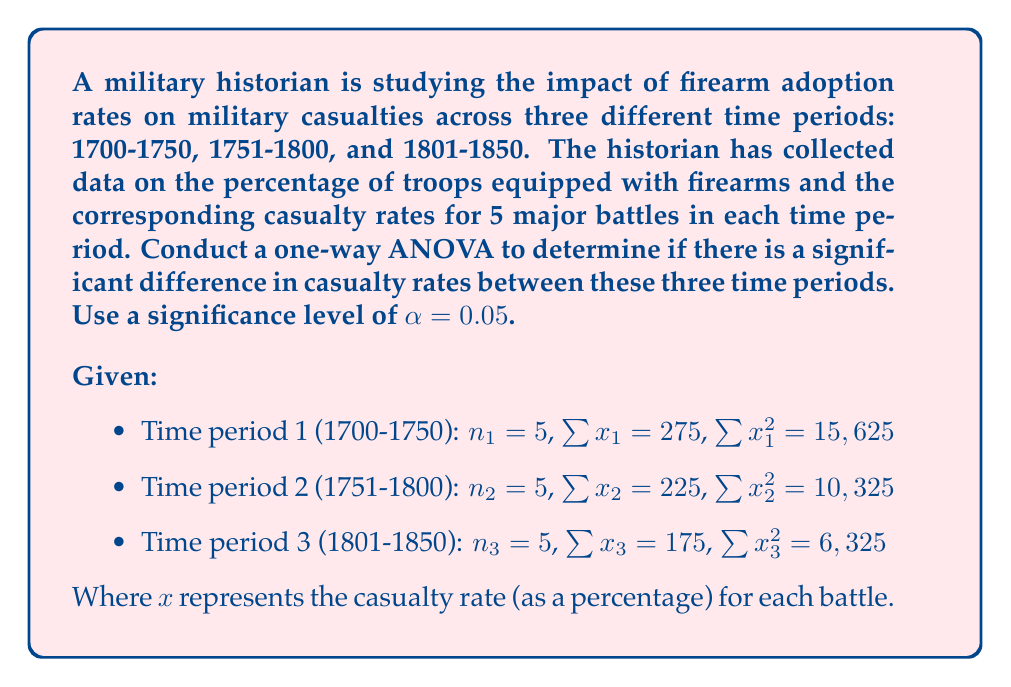Provide a solution to this math problem. To conduct a one-way ANOVA, we need to follow these steps:

1. Calculate the total sum of squares (SST)
2. Calculate the between-group sum of squares (SSB)
3. Calculate the within-group sum of squares (SSW)
4. Calculate the degrees of freedom (df)
5. Calculate the mean squares (MS)
6. Calculate the F-statistic
7. Compare the F-statistic to the critical F-value

Step 1: Calculate SST
First, we need to find the grand mean:
$$\bar{x} = \frac{\sum x_1 + \sum x_2 + \sum x_3}{n_1 + n_2 + n_3} = \frac{275 + 225 + 175}{15} = 45$$

Now, we can calculate SST:
$$SST = \sum x_1^2 + \sum x_2^2 + \sum x_3^2 - \frac{(\sum x_1 + \sum x_2 + \sum x_3)^2}{N}$$
$$SST = 15,625 + 10,325 + 6,325 - \frac{(275 + 225 + 175)^2}{15} = 32,275 - 30,375 = 1,900$$

Step 2: Calculate SSB
$$SSB = \frac{(\sum x_1)^2}{n_1} + \frac{(\sum x_2)^2}{n_2} + \frac{(\sum x_3)^2}{n_3} - \frac{(\sum x_1 + \sum x_2 + \sum x_3)^2}{N}$$
$$SSB = \frac{275^2}{5} + \frac{225^2}{5} + \frac{175^2}{5} - 30,375 = 31,625 - 30,375 = 1,250$$

Step 3: Calculate SSW
$$SSW = SST - SSB = 1,900 - 1,250 = 650$$

Step 4: Calculate degrees of freedom
- Between-group df: $k - 1 = 3 - 1 = 2$
- Within-group df: $N - k = 15 - 3 = 12$
- Total df: $N - 1 = 15 - 1 = 14$

Step 5: Calculate mean squares
$$MSB = \frac{SSB}{df_B} = \frac{1,250}{2} = 625$$
$$MSW = \frac{SSW}{df_W} = \frac{650}{12} = 54.17$$

Step 6: Calculate F-statistic
$$F = \frac{MSB}{MSW} = \frac{625}{54.17} = 11.54$$

Step 7: Compare F-statistic to critical F-value
At α = 0.05, with df_B = 2 and df_W = 12, the critical F-value is approximately 3.89.

Since our calculated F-statistic (11.54) is greater than the critical F-value (3.89), we reject the null hypothesis.
Answer: The one-way ANOVA results show a significant difference in casualty rates between the three time periods (F(2, 12) = 11.54, p < 0.05). This suggests that the adoption of firearms had a significant impact on military casualties over time. 